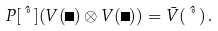Convert formula to latex. <formula><loc_0><loc_0><loc_500><loc_500>P [ \hat { \nu } ] ( V ( \Lambda ) \otimes V ( \Lambda ) ) = \bar { V } ( \hat { \nu } ) \, .</formula> 